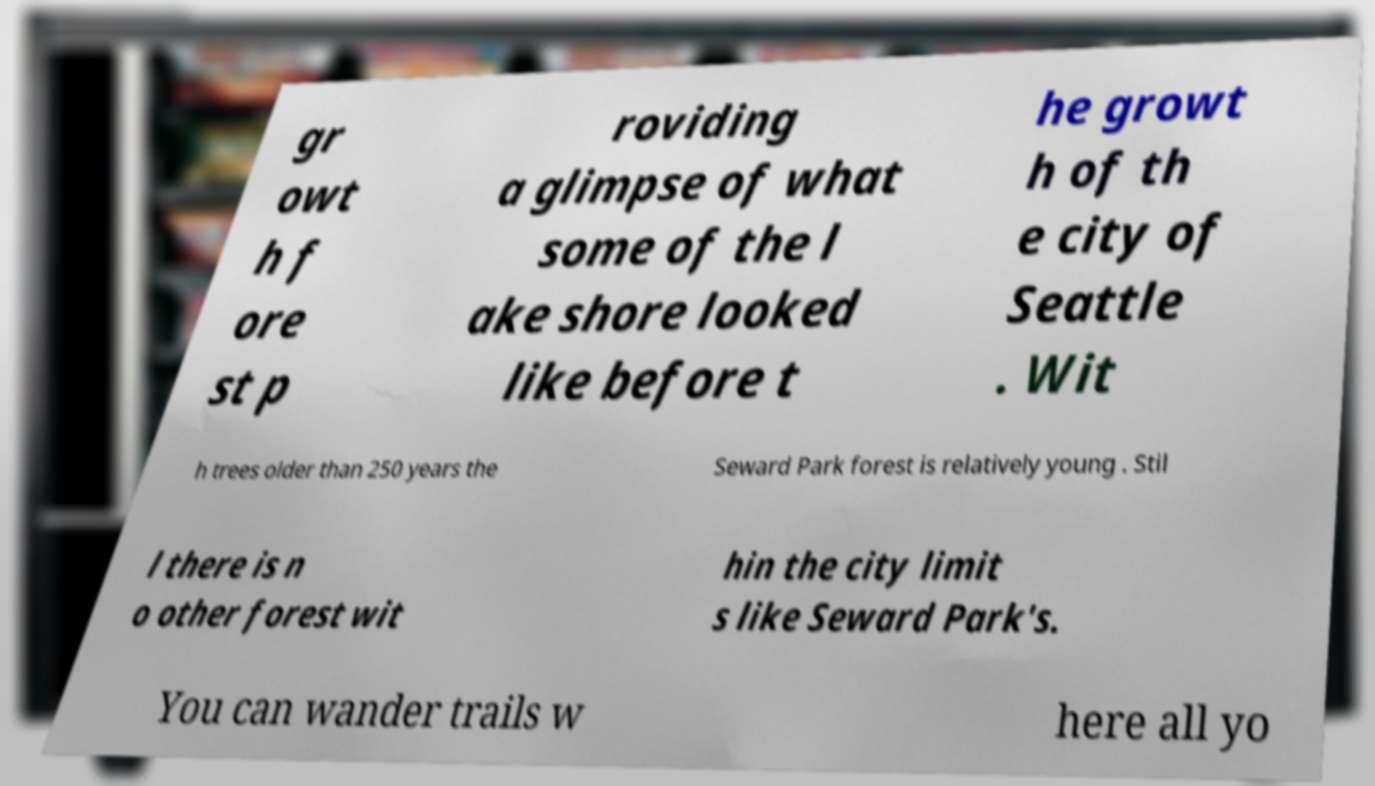Please identify and transcribe the text found in this image. gr owt h f ore st p roviding a glimpse of what some of the l ake shore looked like before t he growt h of th e city of Seattle . Wit h trees older than 250 years the Seward Park forest is relatively young . Stil l there is n o other forest wit hin the city limit s like Seward Park's. You can wander trails w here all yo 